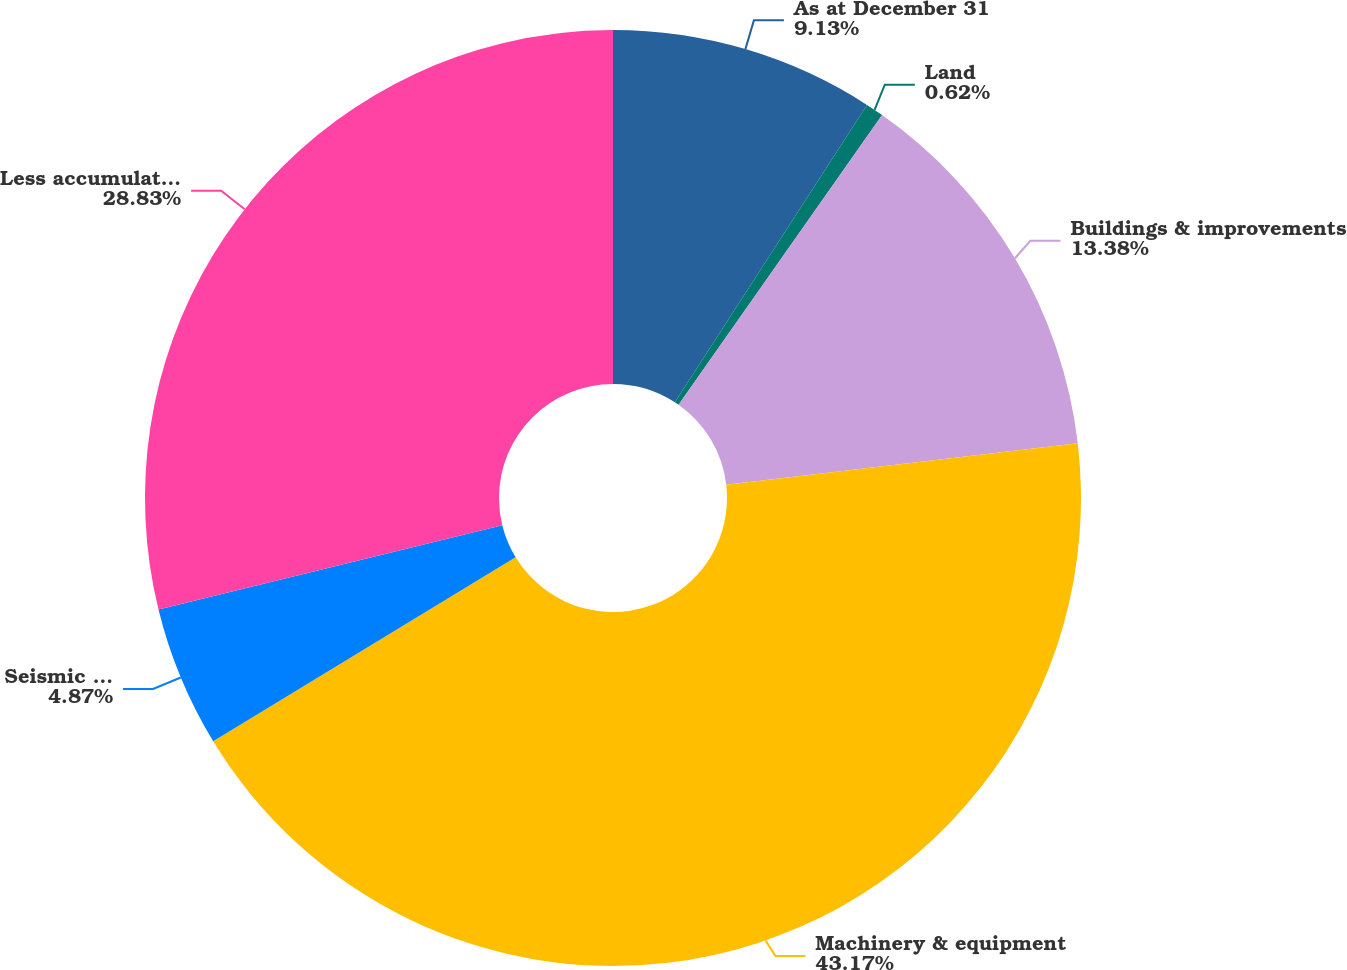<chart> <loc_0><loc_0><loc_500><loc_500><pie_chart><fcel>As at December 31<fcel>Land<fcel>Buildings & improvements<fcel>Machinery & equipment<fcel>Seismic vessels<fcel>Less accumulated depreciation<nl><fcel>9.13%<fcel>0.62%<fcel>13.38%<fcel>43.17%<fcel>4.87%<fcel>28.83%<nl></chart> 